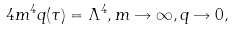<formula> <loc_0><loc_0><loc_500><loc_500>4 m ^ { 4 } q ( \tau ) = \Lambda ^ { 4 } , m \rightarrow \infty , q \rightarrow 0 ,</formula> 